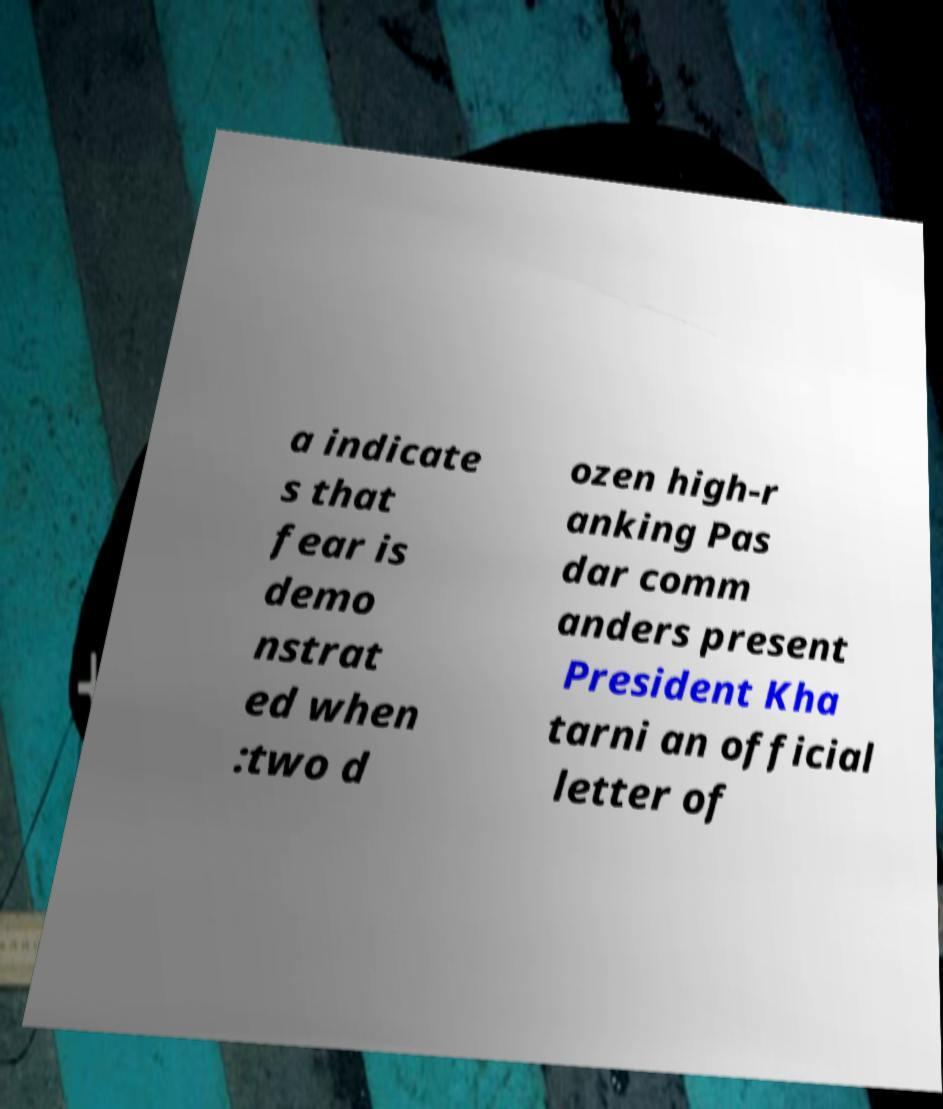There's text embedded in this image that I need extracted. Can you transcribe it verbatim? a indicate s that fear is demo nstrat ed when :two d ozen high-r anking Pas dar comm anders present President Kha tarni an official letter of 